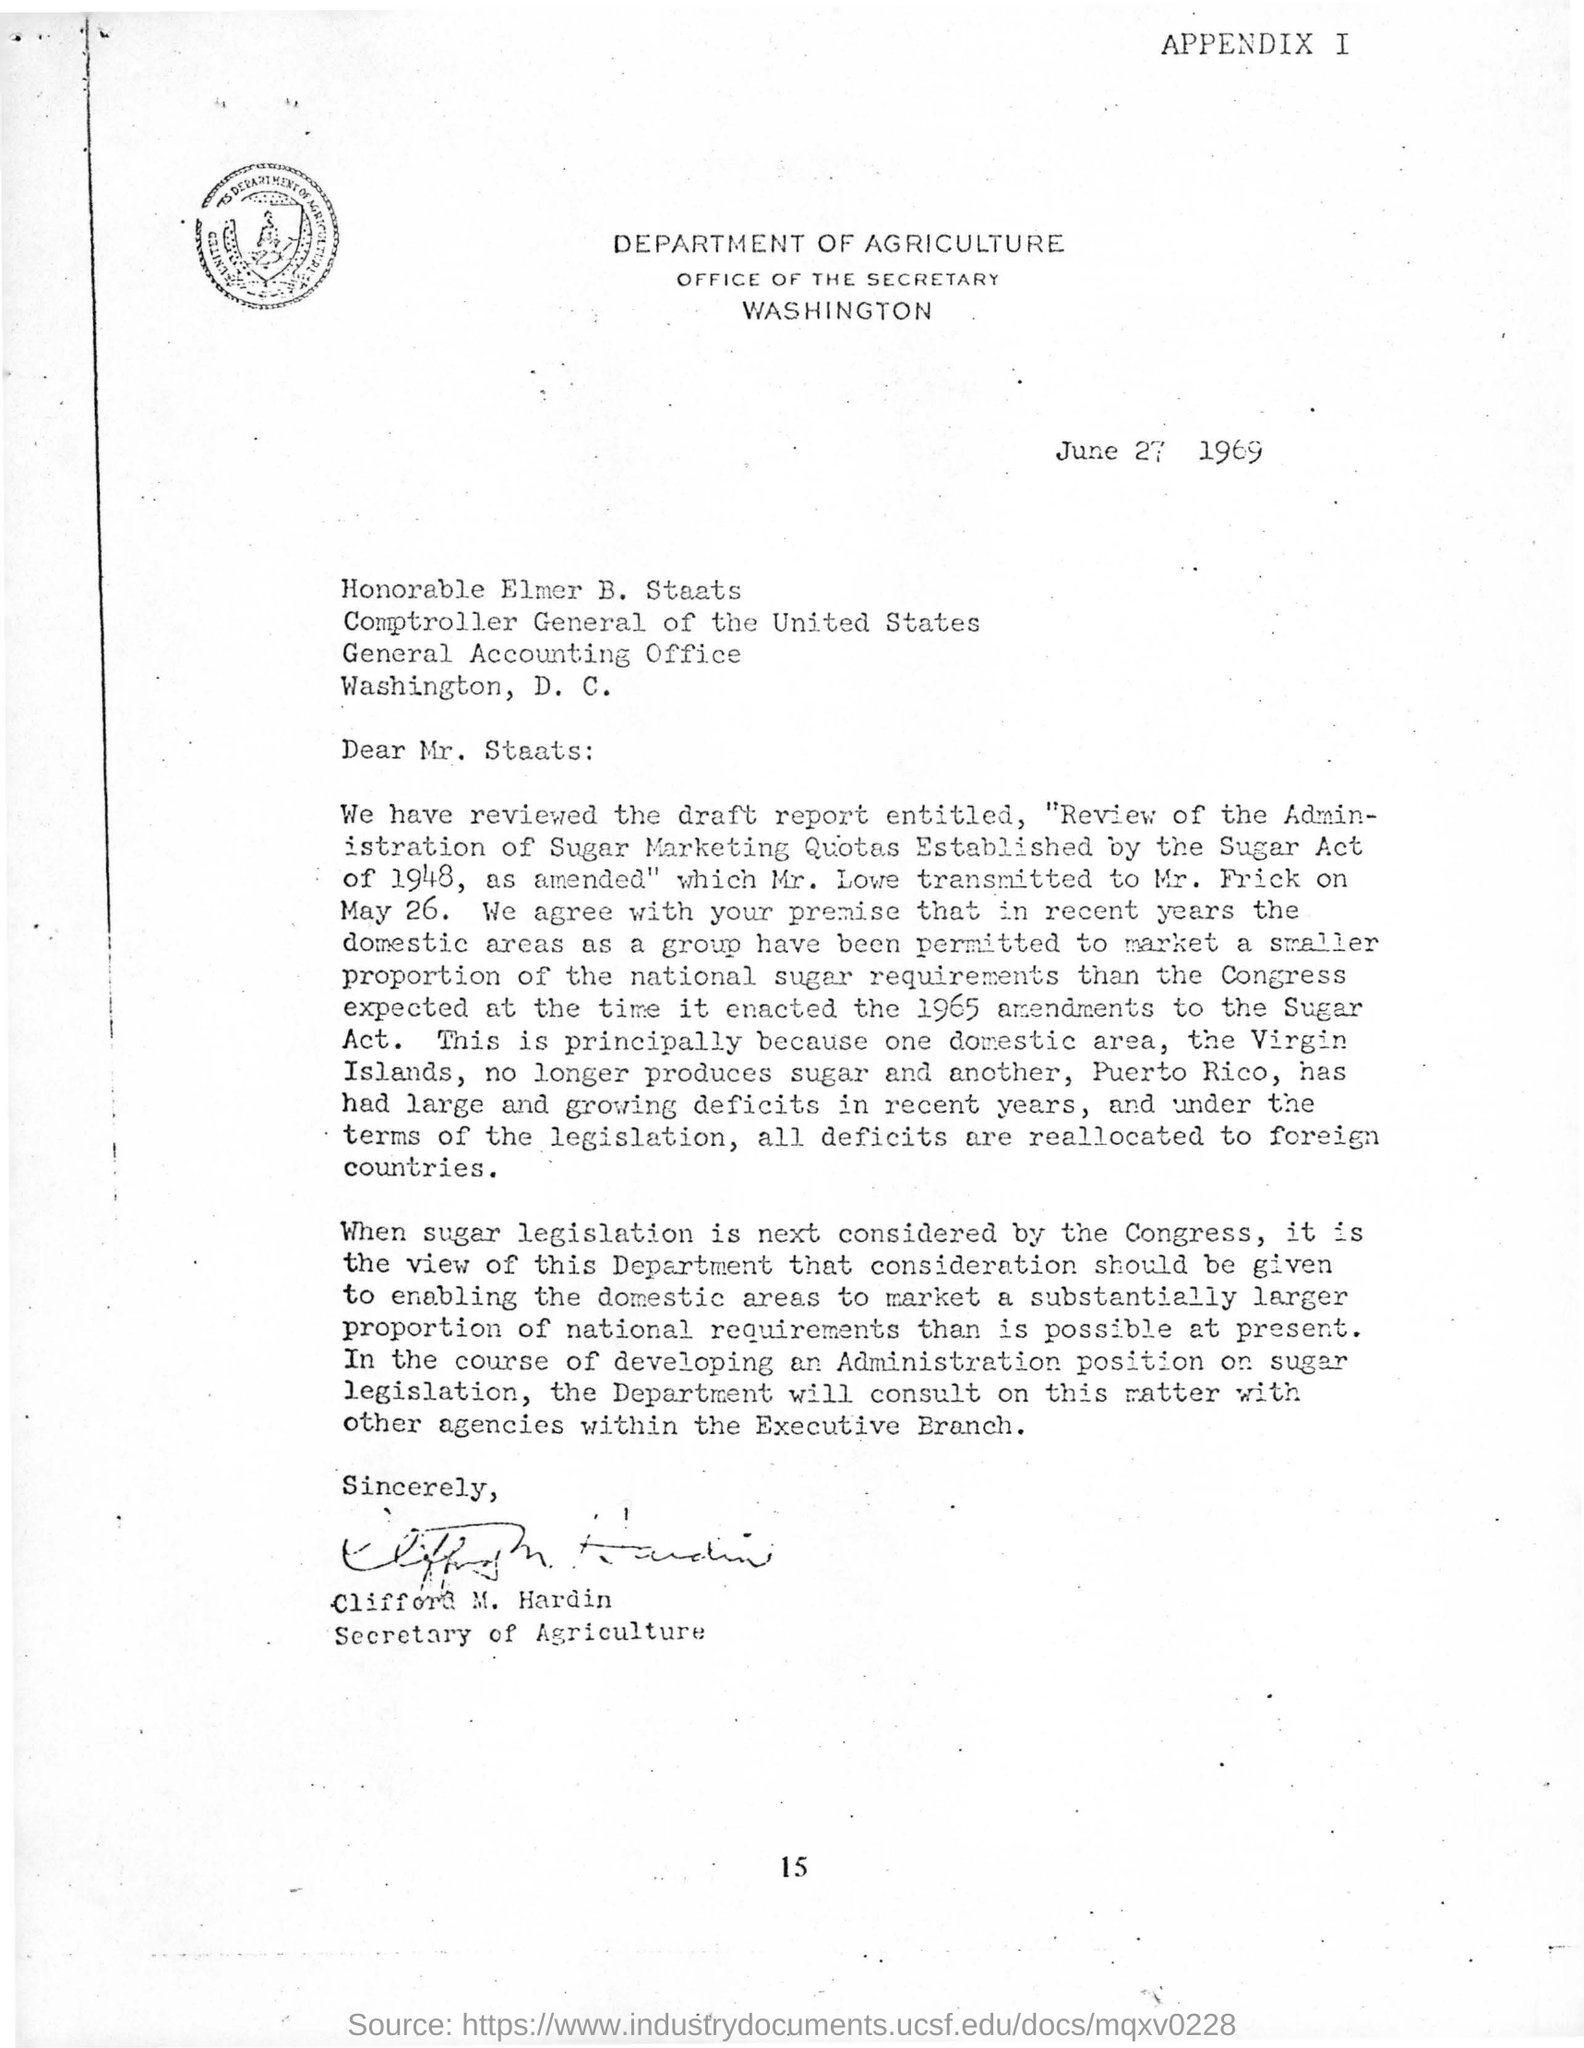List a handful of essential elements in this visual. The document bears the letterhead of the Department of Agriculture. 